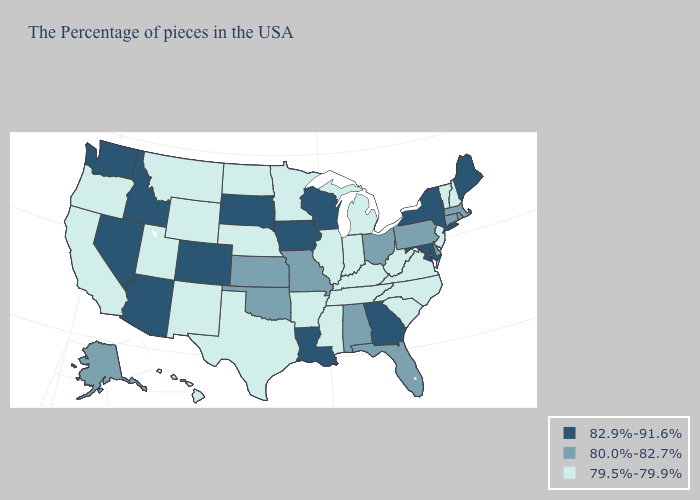Name the states that have a value in the range 79.5%-79.9%?
Concise answer only. New Hampshire, Vermont, New Jersey, Virginia, North Carolina, South Carolina, West Virginia, Michigan, Kentucky, Indiana, Tennessee, Illinois, Mississippi, Arkansas, Minnesota, Nebraska, Texas, North Dakota, Wyoming, New Mexico, Utah, Montana, California, Oregon, Hawaii. Name the states that have a value in the range 80.0%-82.7%?
Concise answer only. Massachusetts, Rhode Island, Connecticut, Delaware, Pennsylvania, Ohio, Florida, Alabama, Missouri, Kansas, Oklahoma, Alaska. What is the value of Minnesota?
Write a very short answer. 79.5%-79.9%. What is the highest value in the MidWest ?
Give a very brief answer. 82.9%-91.6%. Does South Dakota have the same value as Utah?
Quick response, please. No. Name the states that have a value in the range 79.5%-79.9%?
Quick response, please. New Hampshire, Vermont, New Jersey, Virginia, North Carolina, South Carolina, West Virginia, Michigan, Kentucky, Indiana, Tennessee, Illinois, Mississippi, Arkansas, Minnesota, Nebraska, Texas, North Dakota, Wyoming, New Mexico, Utah, Montana, California, Oregon, Hawaii. Does the map have missing data?
Quick response, please. No. Does Washington have the same value as Idaho?
Concise answer only. Yes. Name the states that have a value in the range 80.0%-82.7%?
Be succinct. Massachusetts, Rhode Island, Connecticut, Delaware, Pennsylvania, Ohio, Florida, Alabama, Missouri, Kansas, Oklahoma, Alaska. Among the states that border Indiana , which have the highest value?
Be succinct. Ohio. Among the states that border New Hampshire , which have the lowest value?
Answer briefly. Vermont. What is the value of Washington?
Concise answer only. 82.9%-91.6%. Name the states that have a value in the range 80.0%-82.7%?
Write a very short answer. Massachusetts, Rhode Island, Connecticut, Delaware, Pennsylvania, Ohio, Florida, Alabama, Missouri, Kansas, Oklahoma, Alaska. Name the states that have a value in the range 82.9%-91.6%?
Be succinct. Maine, New York, Maryland, Georgia, Wisconsin, Louisiana, Iowa, South Dakota, Colorado, Arizona, Idaho, Nevada, Washington. Is the legend a continuous bar?
Answer briefly. No. 